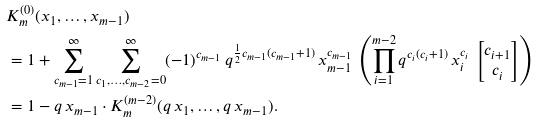<formula> <loc_0><loc_0><loc_500><loc_500>& K _ { m } ^ { ( 0 ) } ( x _ { 1 } , \dots , x _ { m - 1 } ) \\ & = 1 + \sum _ { c _ { m - 1 } = 1 } ^ { \infty } \sum _ { c _ { 1 } , \dots , c _ { m - 2 } = 0 } ^ { \infty } ( - 1 ) ^ { c _ { m - 1 } } \, q ^ { \frac { 1 } { 2 } c _ { m - 1 } ( c _ { m - 1 } + 1 ) } \, x _ { m - 1 } ^ { c _ { m - 1 } } \, \left ( \prod _ { i = 1 } ^ { m - 2 } q ^ { c _ { i } ( c _ { i } + 1 ) } \, x _ { i } ^ { c _ { i } } \, \begin{bmatrix} c _ { i + 1 } \\ c _ { i } \end{bmatrix} \right ) \\ & = 1 - q \, x _ { m - 1 } \cdot K _ { m } ^ { ( m - 2 ) } ( q \, x _ { 1 } , \dots , q \, x _ { m - 1 } ) .</formula> 